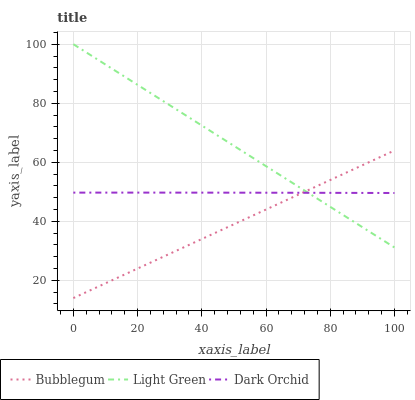Does Bubblegum have the minimum area under the curve?
Answer yes or no. Yes. Does Light Green have the maximum area under the curve?
Answer yes or no. Yes. Does Light Green have the minimum area under the curve?
Answer yes or no. No. Does Bubblegum have the maximum area under the curve?
Answer yes or no. No. Is Bubblegum the smoothest?
Answer yes or no. Yes. Is Dark Orchid the roughest?
Answer yes or no. Yes. Is Light Green the smoothest?
Answer yes or no. No. Is Light Green the roughest?
Answer yes or no. No. Does Bubblegum have the lowest value?
Answer yes or no. Yes. Does Light Green have the lowest value?
Answer yes or no. No. Does Light Green have the highest value?
Answer yes or no. Yes. Does Bubblegum have the highest value?
Answer yes or no. No. Does Light Green intersect Bubblegum?
Answer yes or no. Yes. Is Light Green less than Bubblegum?
Answer yes or no. No. Is Light Green greater than Bubblegum?
Answer yes or no. No. 